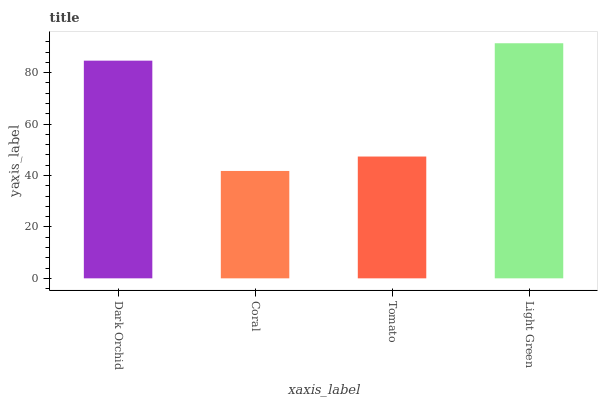Is Coral the minimum?
Answer yes or no. Yes. Is Light Green the maximum?
Answer yes or no. Yes. Is Tomato the minimum?
Answer yes or no. No. Is Tomato the maximum?
Answer yes or no. No. Is Tomato greater than Coral?
Answer yes or no. Yes. Is Coral less than Tomato?
Answer yes or no. Yes. Is Coral greater than Tomato?
Answer yes or no. No. Is Tomato less than Coral?
Answer yes or no. No. Is Dark Orchid the high median?
Answer yes or no. Yes. Is Tomato the low median?
Answer yes or no. Yes. Is Tomato the high median?
Answer yes or no. No. Is Light Green the low median?
Answer yes or no. No. 